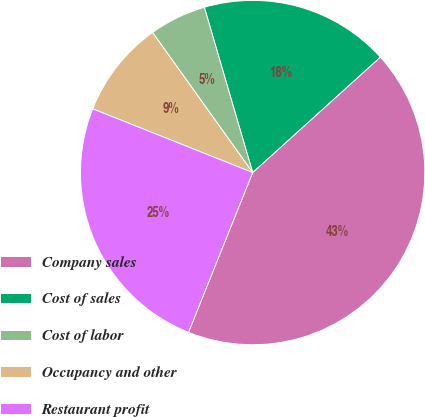<chart> <loc_0><loc_0><loc_500><loc_500><pie_chart><fcel>Company sales<fcel>Cost of sales<fcel>Cost of labor<fcel>Occupancy and other<fcel>Restaurant profit<nl><fcel>42.78%<fcel>17.83%<fcel>5.35%<fcel>9.09%<fcel>24.96%<nl></chart> 